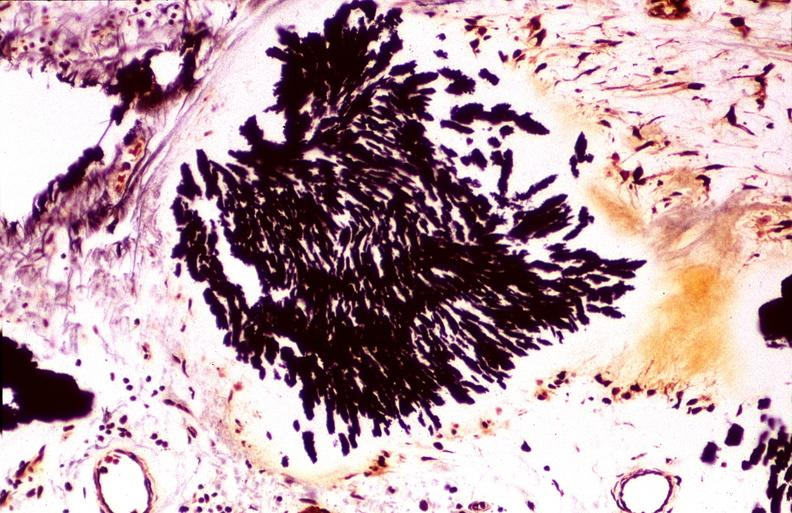does this image show gout, alcohol fixed tissues, monosodium urate crystals?
Answer the question using a single word or phrase. Yes 